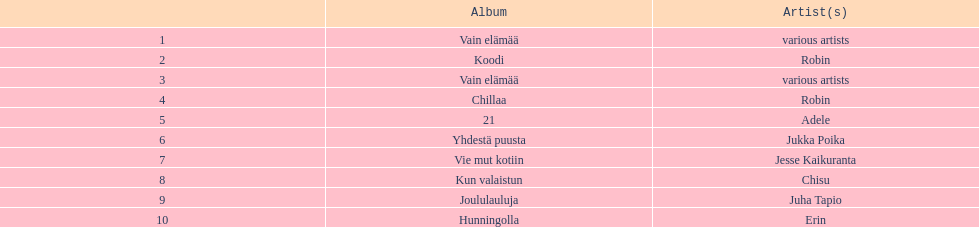For which album with no attributed artist has the greatest number of sales been recorded? Vain elämää. 